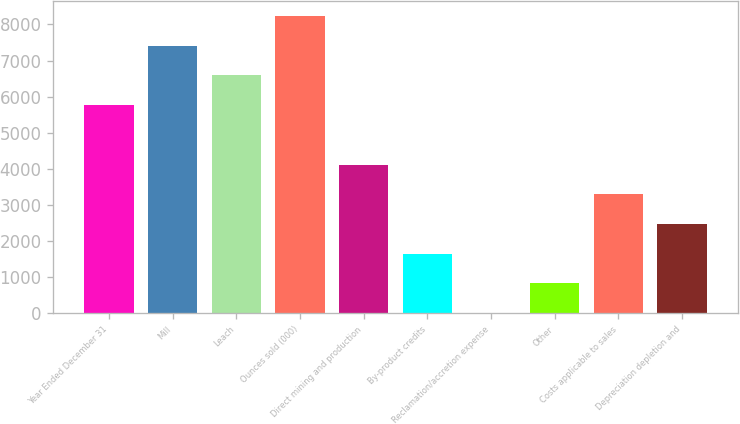<chart> <loc_0><loc_0><loc_500><loc_500><bar_chart><fcel>Year Ended December 31<fcel>Mill<fcel>Leach<fcel>Ounces sold (000)<fcel>Direct mining and production<fcel>By-product credits<fcel>Reclamation/accretion expense<fcel>Other<fcel>Costs applicable to sales<fcel>Depreciation depletion and<nl><fcel>5766.5<fcel>7413.5<fcel>6590<fcel>8237<fcel>4119.5<fcel>1649<fcel>2<fcel>825.5<fcel>3296<fcel>2472.5<nl></chart> 